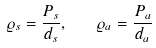Convert formula to latex. <formula><loc_0><loc_0><loc_500><loc_500>\varrho _ { s } = \frac { P _ { s } } { d _ { s } } , \quad \varrho _ { a } = \frac { P _ { a } } { d _ { a } }</formula> 